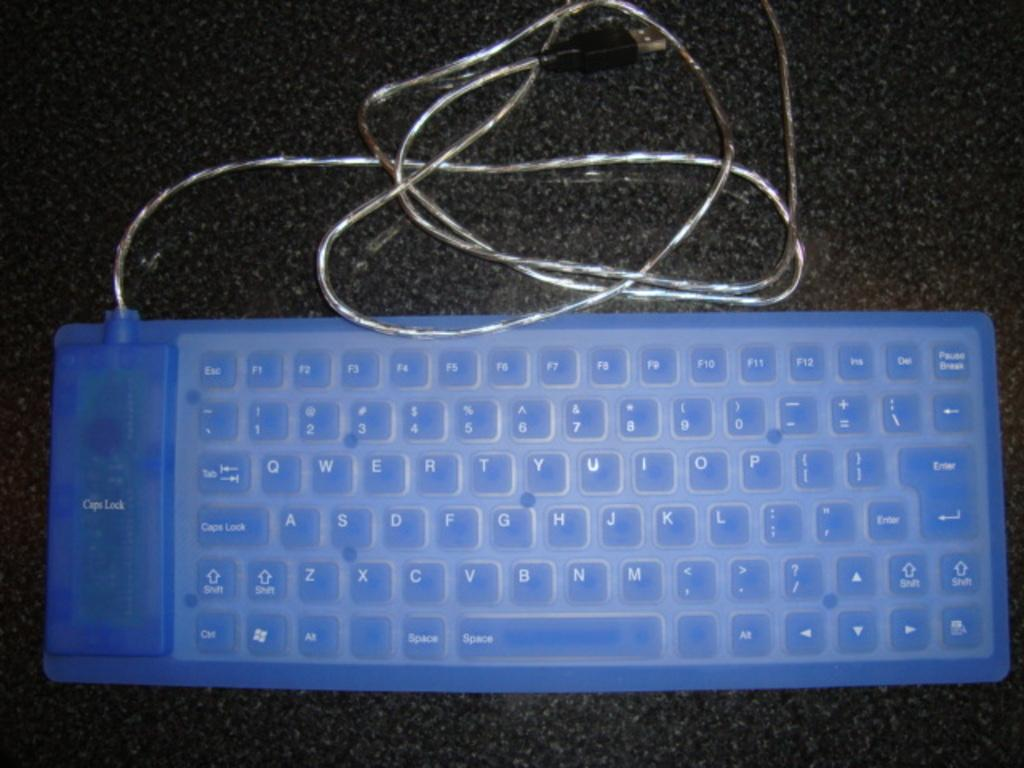<image>
Provide a brief description of the given image. A clear blue QWERTY style keyboard has an extra plug on it. 